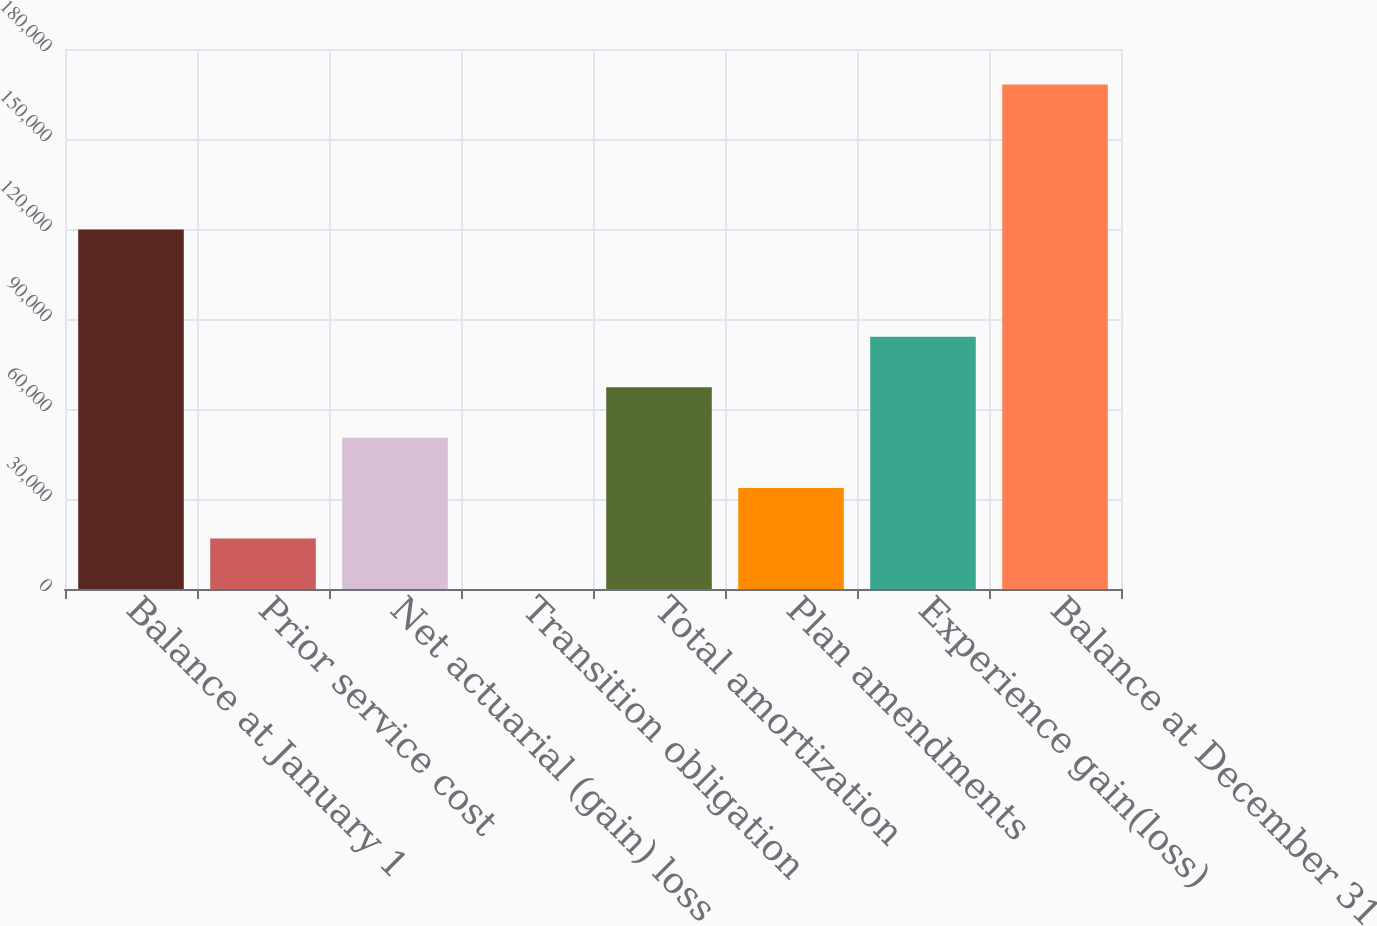Convert chart to OTSL. <chart><loc_0><loc_0><loc_500><loc_500><bar_chart><fcel>Balance at January 1<fcel>Prior service cost<fcel>Net actuarial (gain) loss<fcel>Transition obligation<fcel>Total amortization<fcel>Plan amendments<fcel>Experience gain(loss)<fcel>Balance at December 31<nl><fcel>119863<fcel>16814.5<fcel>50439.9<fcel>1.74<fcel>67252.7<fcel>33627.2<fcel>84065.4<fcel>168129<nl></chart> 